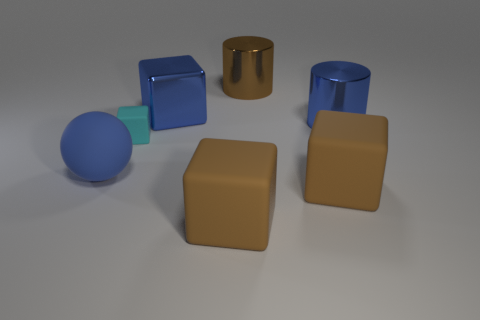Add 1 tiny green metallic objects. How many objects exist? 8 Subtract all blocks. How many objects are left? 3 Subtract all brown cylinders. Subtract all blue shiny cubes. How many objects are left? 5 Add 4 blue spheres. How many blue spheres are left? 5 Add 2 big cyan spheres. How many big cyan spheres exist? 2 Subtract 0 green cylinders. How many objects are left? 7 